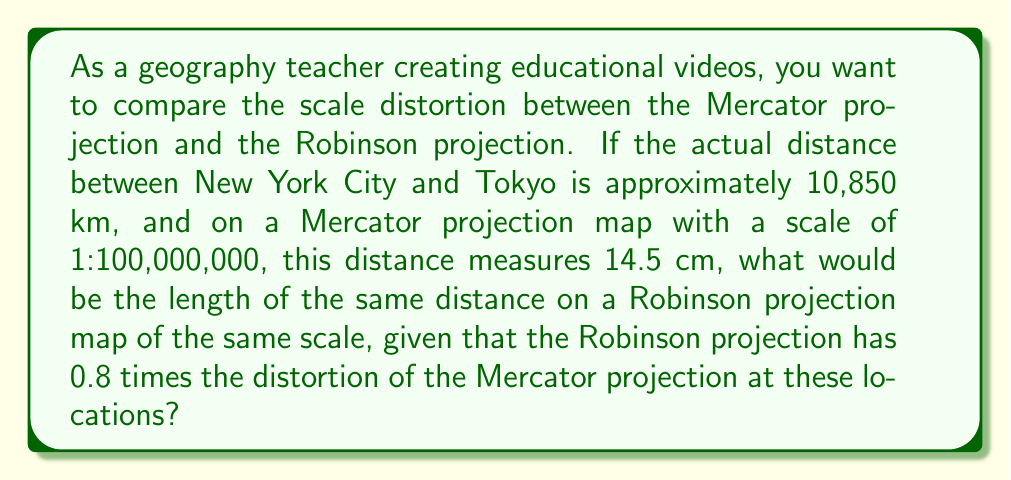Can you solve this math problem? Let's approach this step-by-step:

1) First, let's calculate the scale factor of the Mercator projection:
   
   Actual distance = 10,850 km = 10,850,000,000 cm
   Map distance (Mercator) = 14.5 cm
   
   Scale factor = $\frac{\text{Map distance}}{\text{Actual distance}} = \frac{14.5}{10,850,000,000} = 1.33641 \times 10^{-9}$

2) This scale factor includes both the map scale (1:100,000,000) and the Mercator distortion. Let's call the Mercator distortion factor $x$:

   $1.33641 \times 10^{-9} = \frac{1}{100,000,000} \times x$
   
   $x = 1.33641$

3) Now, we know that the Robinson projection has 0.8 times the distortion of the Mercator projection:

   Robinson distortion factor = $0.8 \times 1.33641 = 1.069128$

4) To find the length on the Robinson projection, we multiply the actual distance by the map scale and the Robinson distortion factor:

   Robinson length = $10,850,000,000 \times \frac{1}{100,000,000} \times 1.069128$
                   = $10,850 \times 1.069128$
                   = 11.6 cm (rounded to one decimal place)
Answer: 11.6 cm 